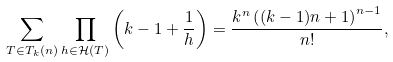<formula> <loc_0><loc_0><loc_500><loc_500>\sum _ { T \in T _ { k } ( n ) } & \prod _ { h \in \mathcal { H } ( T ) } \left ( k - 1 + \frac { 1 } { h } \right ) = \frac { k ^ { n } \left ( ( k - 1 ) n + 1 \right ) ^ { n - 1 } } { n ! } ,</formula> 